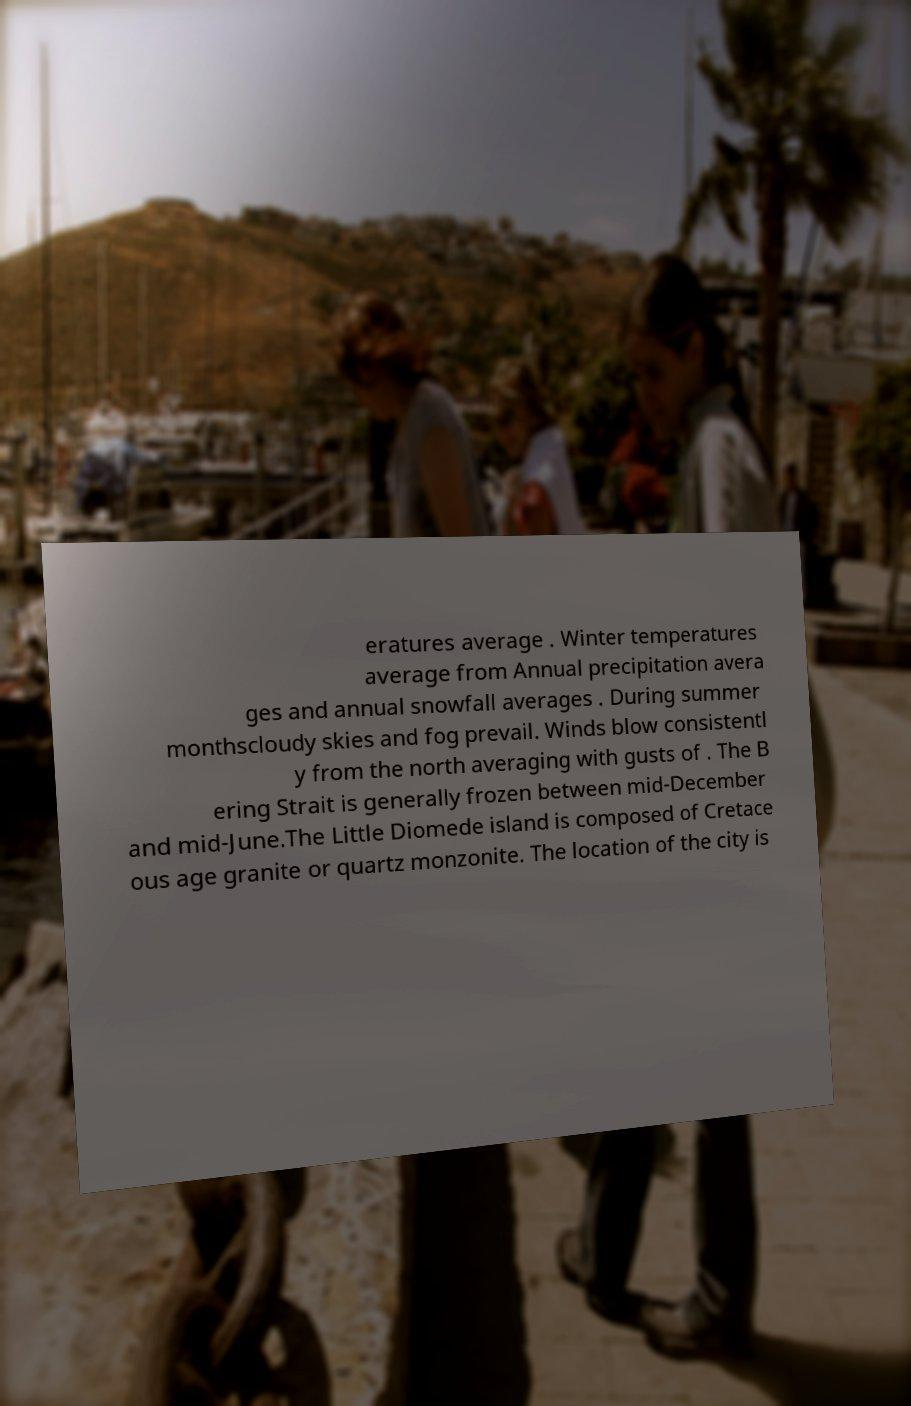For documentation purposes, I need the text within this image transcribed. Could you provide that? eratures average . Winter temperatures average from Annual precipitation avera ges and annual snowfall averages . During summer monthscloudy skies and fog prevail. Winds blow consistentl y from the north averaging with gusts of . The B ering Strait is generally frozen between mid-December and mid-June.The Little Diomede island is composed of Cretace ous age granite or quartz monzonite. The location of the city is 